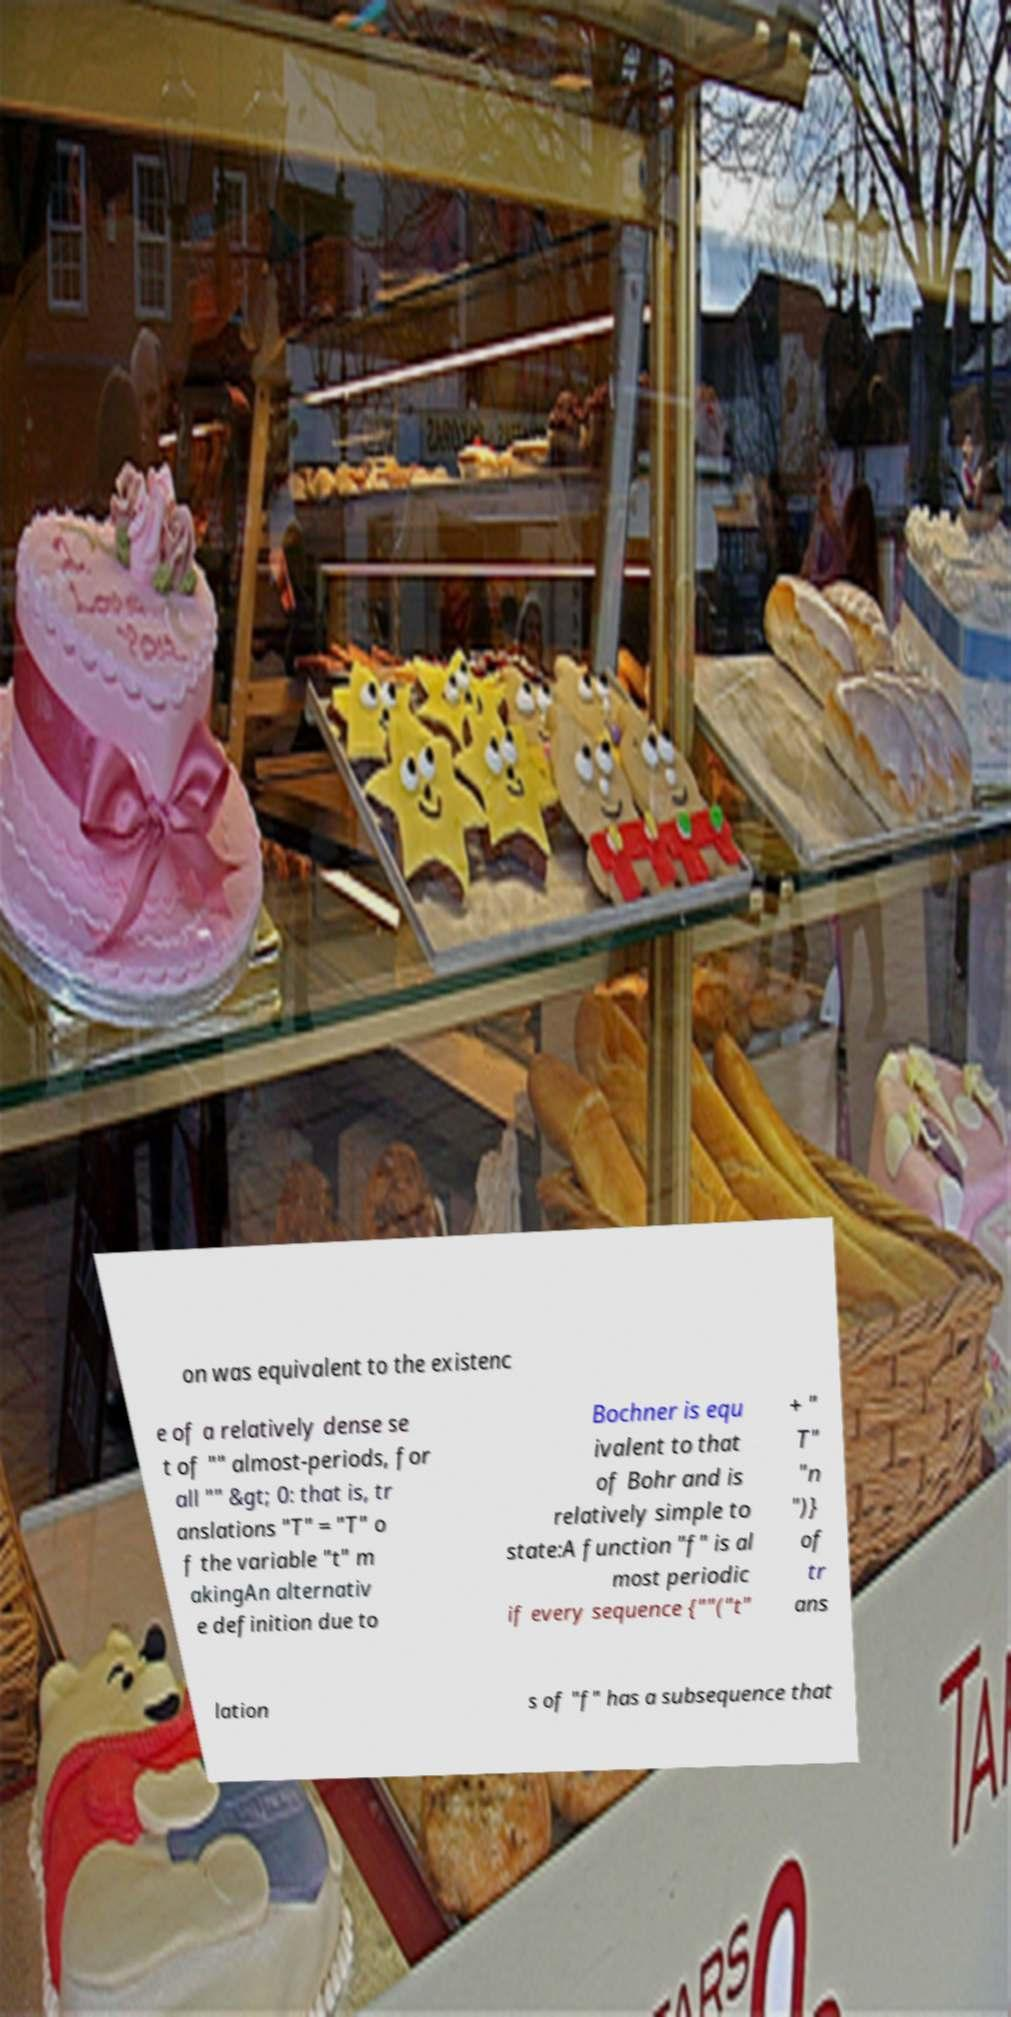Please identify and transcribe the text found in this image. on was equivalent to the existenc e of a relatively dense se t of "" almost-periods, for all "" &gt; 0: that is, tr anslations "T" = "T" o f the variable "t" m akingAn alternativ e definition due to Bochner is equ ivalent to that of Bohr and is relatively simple to state:A function "f" is al most periodic if every sequence {""("t" + " T" "n ")} of tr ans lation s of "f" has a subsequence that 